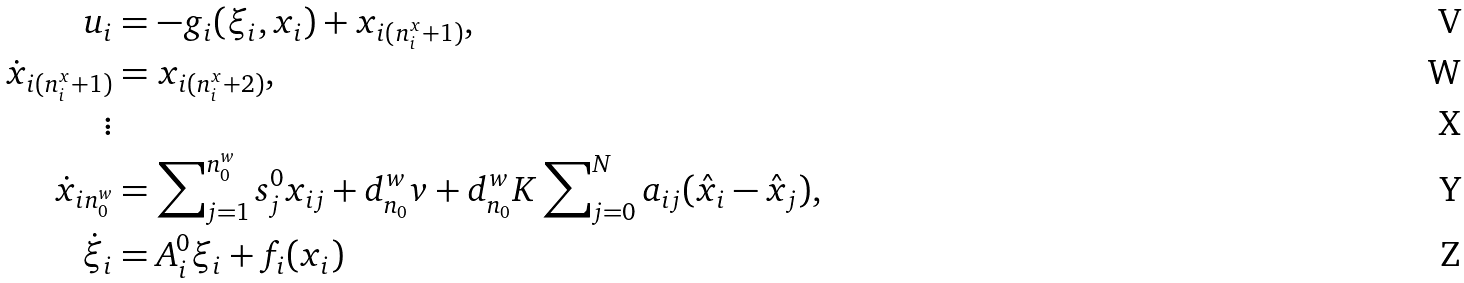<formula> <loc_0><loc_0><loc_500><loc_500>u _ { i } & = - g _ { i } ( \xi _ { i } , x _ { i } ) + x _ { i ( n _ { i } ^ { x } + 1 ) } , \\ \dot { x } _ { i ( n _ { i } ^ { x } + 1 ) } & = x _ { i ( n _ { i } ^ { x } + 2 ) } , \\ \vdots \\ \dot { x } _ { i n _ { 0 } ^ { w } } & = \sum \nolimits _ { j = 1 } ^ { n _ { 0 } ^ { w } } s _ { j } ^ { 0 } x _ { i j } + d _ { n _ { 0 } } ^ { w } v + d _ { n _ { 0 } } ^ { w } K \sum \nolimits _ { j = 0 } ^ { N } a _ { i j } ( \hat { x } _ { i } - \hat { x } _ { j } ) , \\ \dot { \xi } _ { i } & = A _ { i } ^ { 0 } \xi _ { i } + f _ { i } ( x _ { i } )</formula> 